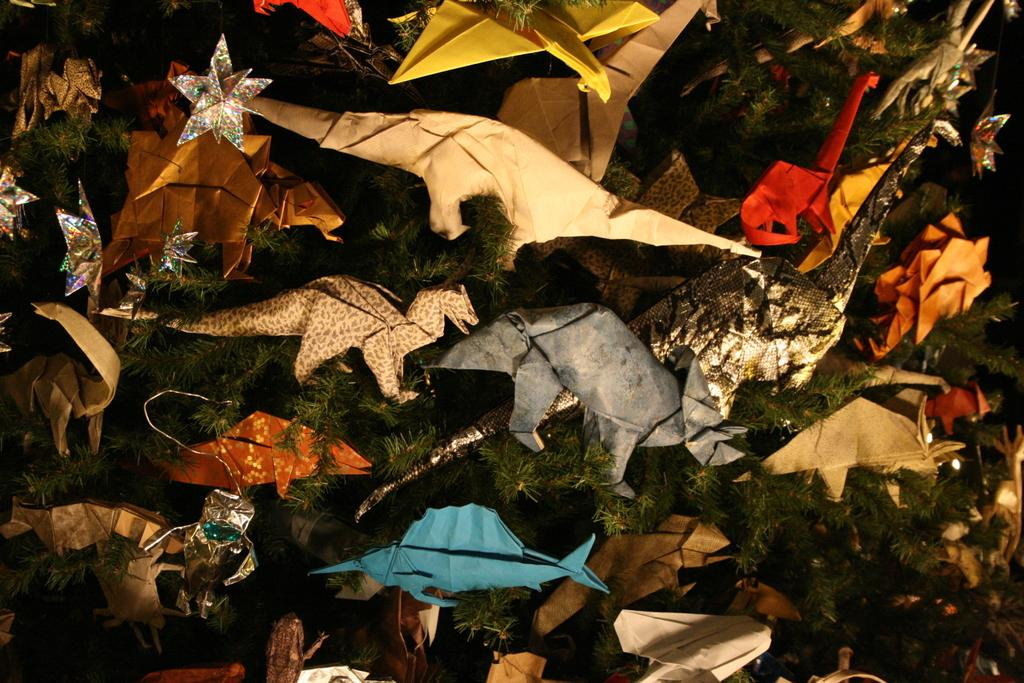What celestial objects are visible in the image? There are stars in the image. What type of objects are made of paper in the image? There are paper toys in the image. Where are the paper toys located? The paper toys are on a plant. What type of hydrant is visible in the image? There is no hydrant present in the image. How does the loss of the paper toys affect the image? The image does not depict any loss or change in the paper toys, so it cannot be determined how their absence would affect the image. 